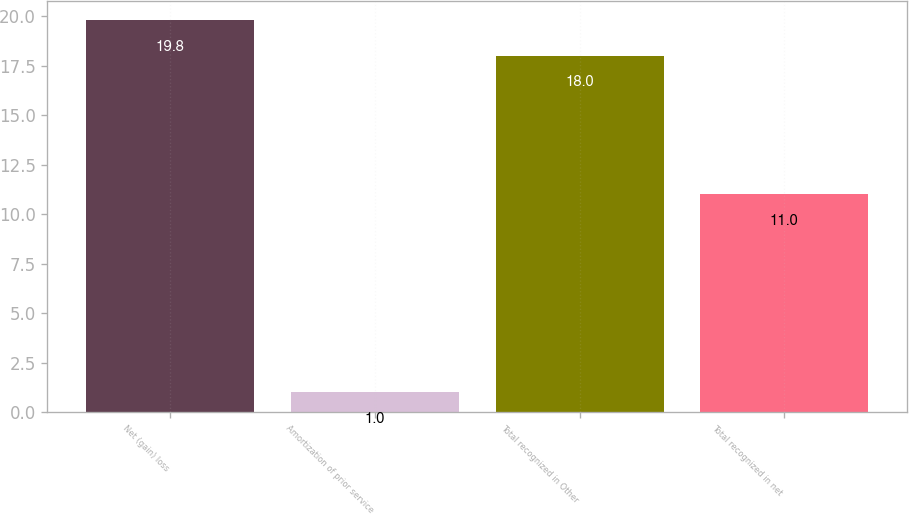<chart> <loc_0><loc_0><loc_500><loc_500><bar_chart><fcel>Net (gain) loss<fcel>Amortization of prior service<fcel>Total recognized in Other<fcel>Total recognized in net<nl><fcel>19.8<fcel>1<fcel>18<fcel>11<nl></chart> 